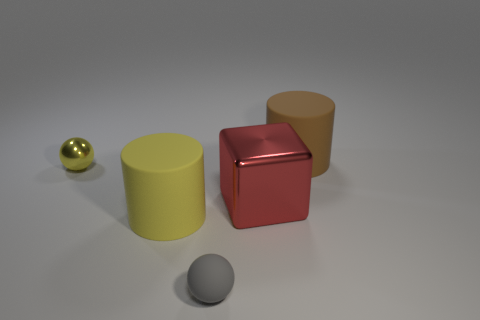How many large objects are brown rubber cylinders or yellow shiny things?
Your response must be concise. 1. What number of tiny objects are there?
Provide a short and direct response. 2. What is the small ball behind the large shiny cube made of?
Give a very brief answer. Metal. Are there any red metallic things right of the big yellow rubber cylinder?
Provide a succinct answer. Yes. Does the yellow cylinder have the same size as the gray sphere?
Your response must be concise. No. How many tiny green spheres are the same material as the small yellow sphere?
Your response must be concise. 0. There is a gray object that is in front of the big cylinder behind the small metal thing; what size is it?
Provide a succinct answer. Small. There is a big thing that is in front of the small shiny sphere and to the right of the yellow rubber object; what color is it?
Offer a very short reply. Red. Does the big yellow rubber object have the same shape as the red thing?
Offer a very short reply. No. There is a thing that is the same color as the small shiny sphere; what size is it?
Offer a very short reply. Large. 